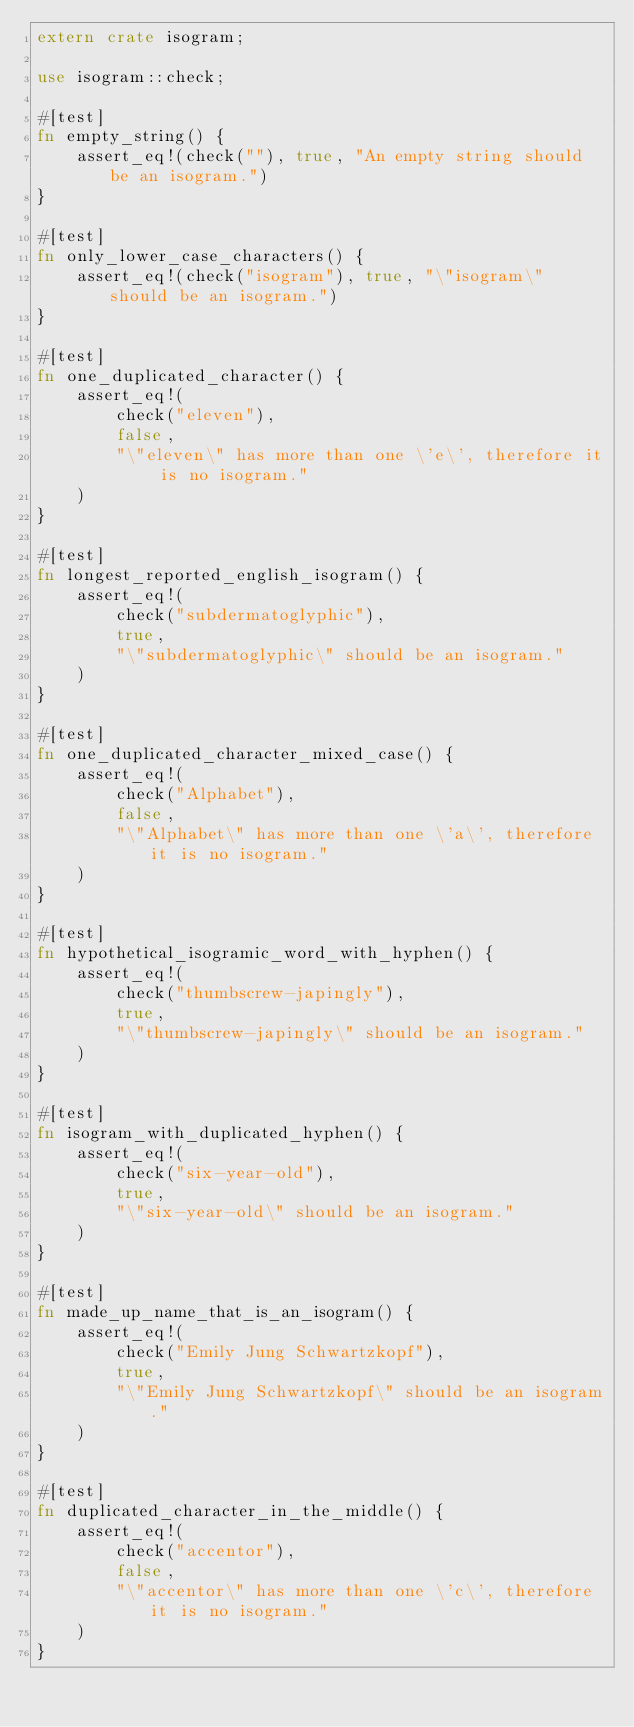<code> <loc_0><loc_0><loc_500><loc_500><_Rust_>extern crate isogram;

use isogram::check;

#[test]
fn empty_string() {
    assert_eq!(check(""), true, "An empty string should be an isogram.")
}

#[test]
fn only_lower_case_characters() {
    assert_eq!(check("isogram"), true, "\"isogram\" should be an isogram.")
}

#[test]
fn one_duplicated_character() {
    assert_eq!(
        check("eleven"),
        false,
        "\"eleven\" has more than one \'e\', therefore it is no isogram."
    )
}

#[test]
fn longest_reported_english_isogram() {
    assert_eq!(
        check("subdermatoglyphic"),
        true,
        "\"subdermatoglyphic\" should be an isogram."
    )
}

#[test]
fn one_duplicated_character_mixed_case() {
    assert_eq!(
        check("Alphabet"),
        false,
        "\"Alphabet\" has more than one \'a\', therefore it is no isogram."
    )
}

#[test]
fn hypothetical_isogramic_word_with_hyphen() {
    assert_eq!(
        check("thumbscrew-japingly"),
        true,
        "\"thumbscrew-japingly\" should be an isogram."
    )
}

#[test]
fn isogram_with_duplicated_hyphen() {
    assert_eq!(
        check("six-year-old"),
        true,
        "\"six-year-old\" should be an isogram."
    )
}

#[test]
fn made_up_name_that_is_an_isogram() {
    assert_eq!(
        check("Emily Jung Schwartzkopf"),
        true,
        "\"Emily Jung Schwartzkopf\" should be an isogram."
    )
}

#[test]
fn duplicated_character_in_the_middle() {
    assert_eq!(
        check("accentor"),
        false,
        "\"accentor\" has more than one \'c\', therefore it is no isogram."
    )
}
</code> 